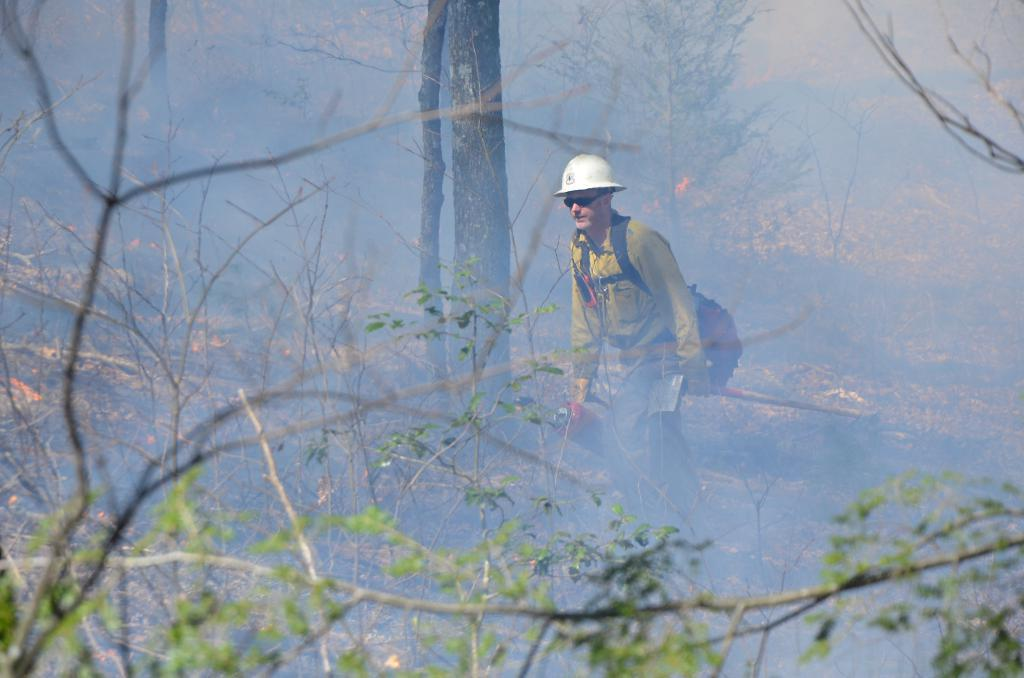Who or what is present in the image? There is a person in the image. What object is visible in the image? There is a bag in the image. What type of natural environment is depicted in the image? There are trees in the image. What is happening in the image that involves heat and combustion? There is fire in the image. What is the result of the fire in the image? There is smoke in the image. What is the purpose of the caption in the image? There is no caption present in the image, so it does not have a purpose in this context. 